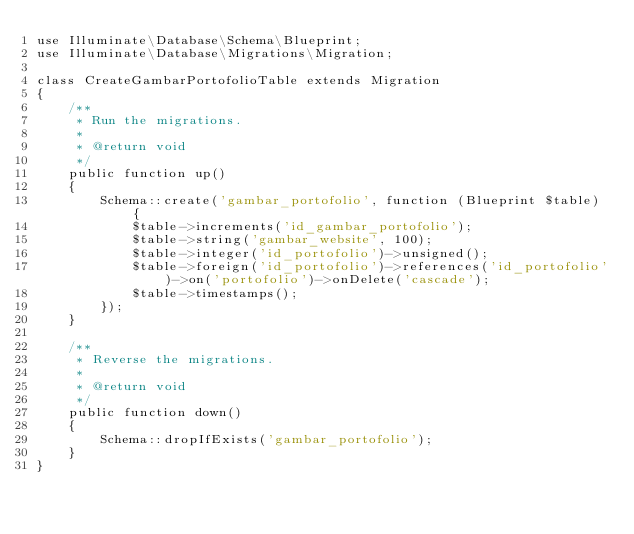<code> <loc_0><loc_0><loc_500><loc_500><_PHP_>use Illuminate\Database\Schema\Blueprint;
use Illuminate\Database\Migrations\Migration;

class CreateGambarPortofolioTable extends Migration
{
    /**
     * Run the migrations.
     *
     * @return void
     */
    public function up()
    {
        Schema::create('gambar_portofolio', function (Blueprint $table) {
            $table->increments('id_gambar_portofolio');
            $table->string('gambar_website', 100);            
            $table->integer('id_portofolio')->unsigned();
            $table->foreign('id_portofolio')->references('id_portofolio')->on('portofolio')->onDelete('cascade');
            $table->timestamps();
        });
    }

    /**
     * Reverse the migrations.
     *
     * @return void
     */
    public function down()
    {
        Schema::dropIfExists('gambar_portofolio');
    }
}
</code> 